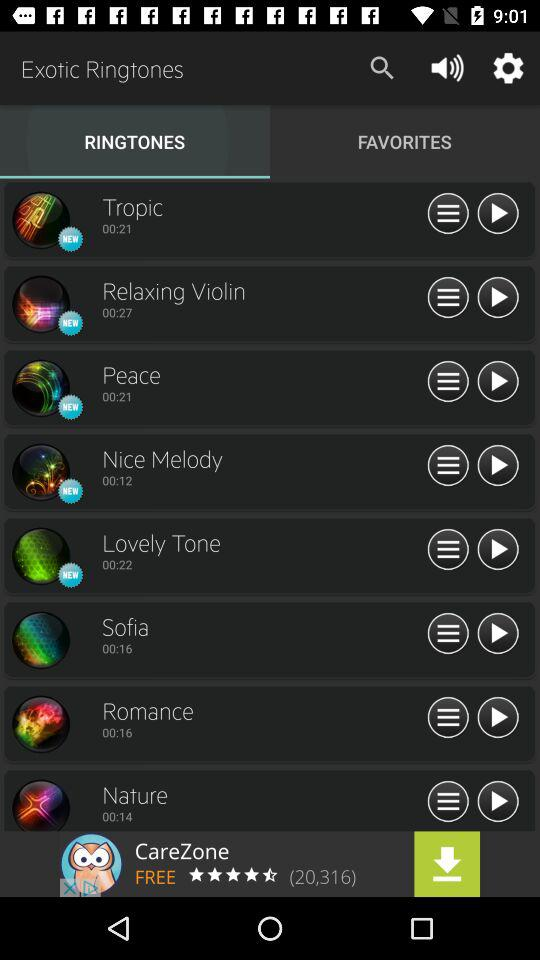What's the name of the new ringtones? The new ringtones are "Tropic", "Relaxing Violin", "Peace", "Nice Melody" and "Lovely Tone". 